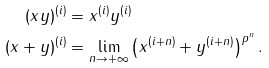<formula> <loc_0><loc_0><loc_500><loc_500>( x y ) ^ { ( i ) } & = x ^ { ( i ) } y ^ { ( i ) } \\ ( x + y ) ^ { ( i ) } & = \lim _ { n \rightarrow + \infty } \left ( x ^ { ( i + n ) } + y ^ { ( i + n ) } \right ) ^ { p ^ { n } } .</formula> 